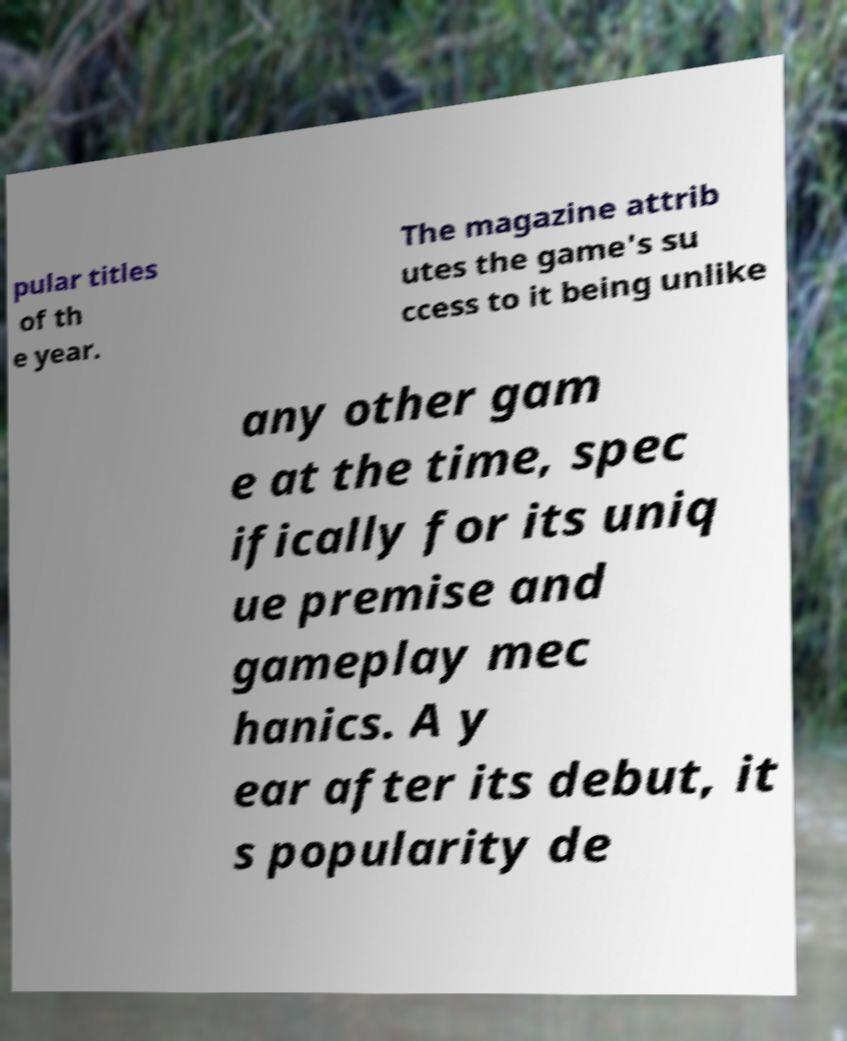Can you read and provide the text displayed in the image?This photo seems to have some interesting text. Can you extract and type it out for me? pular titles of th e year. The magazine attrib utes the game's su ccess to it being unlike any other gam e at the time, spec ifically for its uniq ue premise and gameplay mec hanics. A y ear after its debut, it s popularity de 